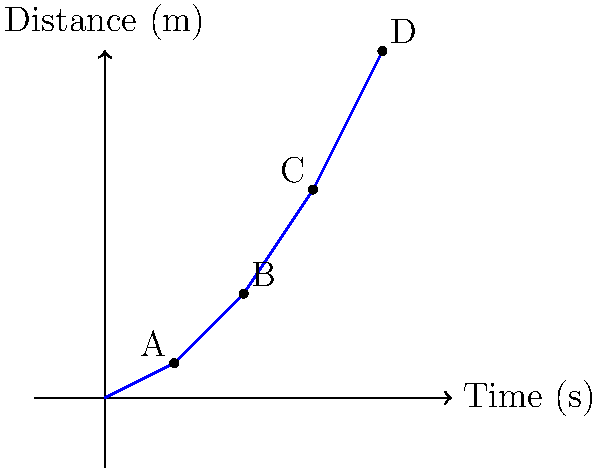The graph shows the distance-time relationship of a person walking away from a press conference. Calculate the average velocity between points B and D. To calculate the average velocity between points B and D, we need to follow these steps:

1. Identify the coordinates of points B and D:
   Point B: (2 s, 1.5 m)
   Point D: (4 s, 5 m)

2. Calculate the change in distance (displacement):
   $\Delta d = d_D - d_B = 5 \text{ m} - 1.5 \text{ m} = 3.5 \text{ m}$

3. Calculate the change in time:
   $\Delta t = t_D - t_B = 4 \text{ s} - 2 \text{ s} = 2 \text{ s}$

4. Use the formula for average velocity:
   $v_{avg} = \frac{\Delta d}{\Delta t}$

5. Substitute the values:
   $v_{avg} = \frac{3.5 \text{ m}}{2 \text{ s}} = 1.75 \text{ m/s}$

Therefore, the average velocity between points B and D is 1.75 m/s.
Answer: 1.75 m/s 